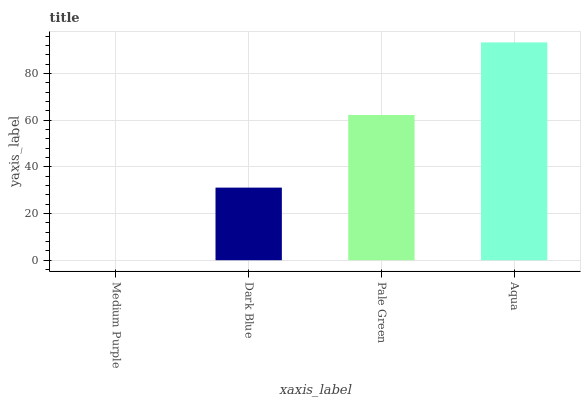Is Medium Purple the minimum?
Answer yes or no. Yes. Is Aqua the maximum?
Answer yes or no. Yes. Is Dark Blue the minimum?
Answer yes or no. No. Is Dark Blue the maximum?
Answer yes or no. No. Is Dark Blue greater than Medium Purple?
Answer yes or no. Yes. Is Medium Purple less than Dark Blue?
Answer yes or no. Yes. Is Medium Purple greater than Dark Blue?
Answer yes or no. No. Is Dark Blue less than Medium Purple?
Answer yes or no. No. Is Pale Green the high median?
Answer yes or no. Yes. Is Dark Blue the low median?
Answer yes or no. Yes. Is Medium Purple the high median?
Answer yes or no. No. Is Medium Purple the low median?
Answer yes or no. No. 